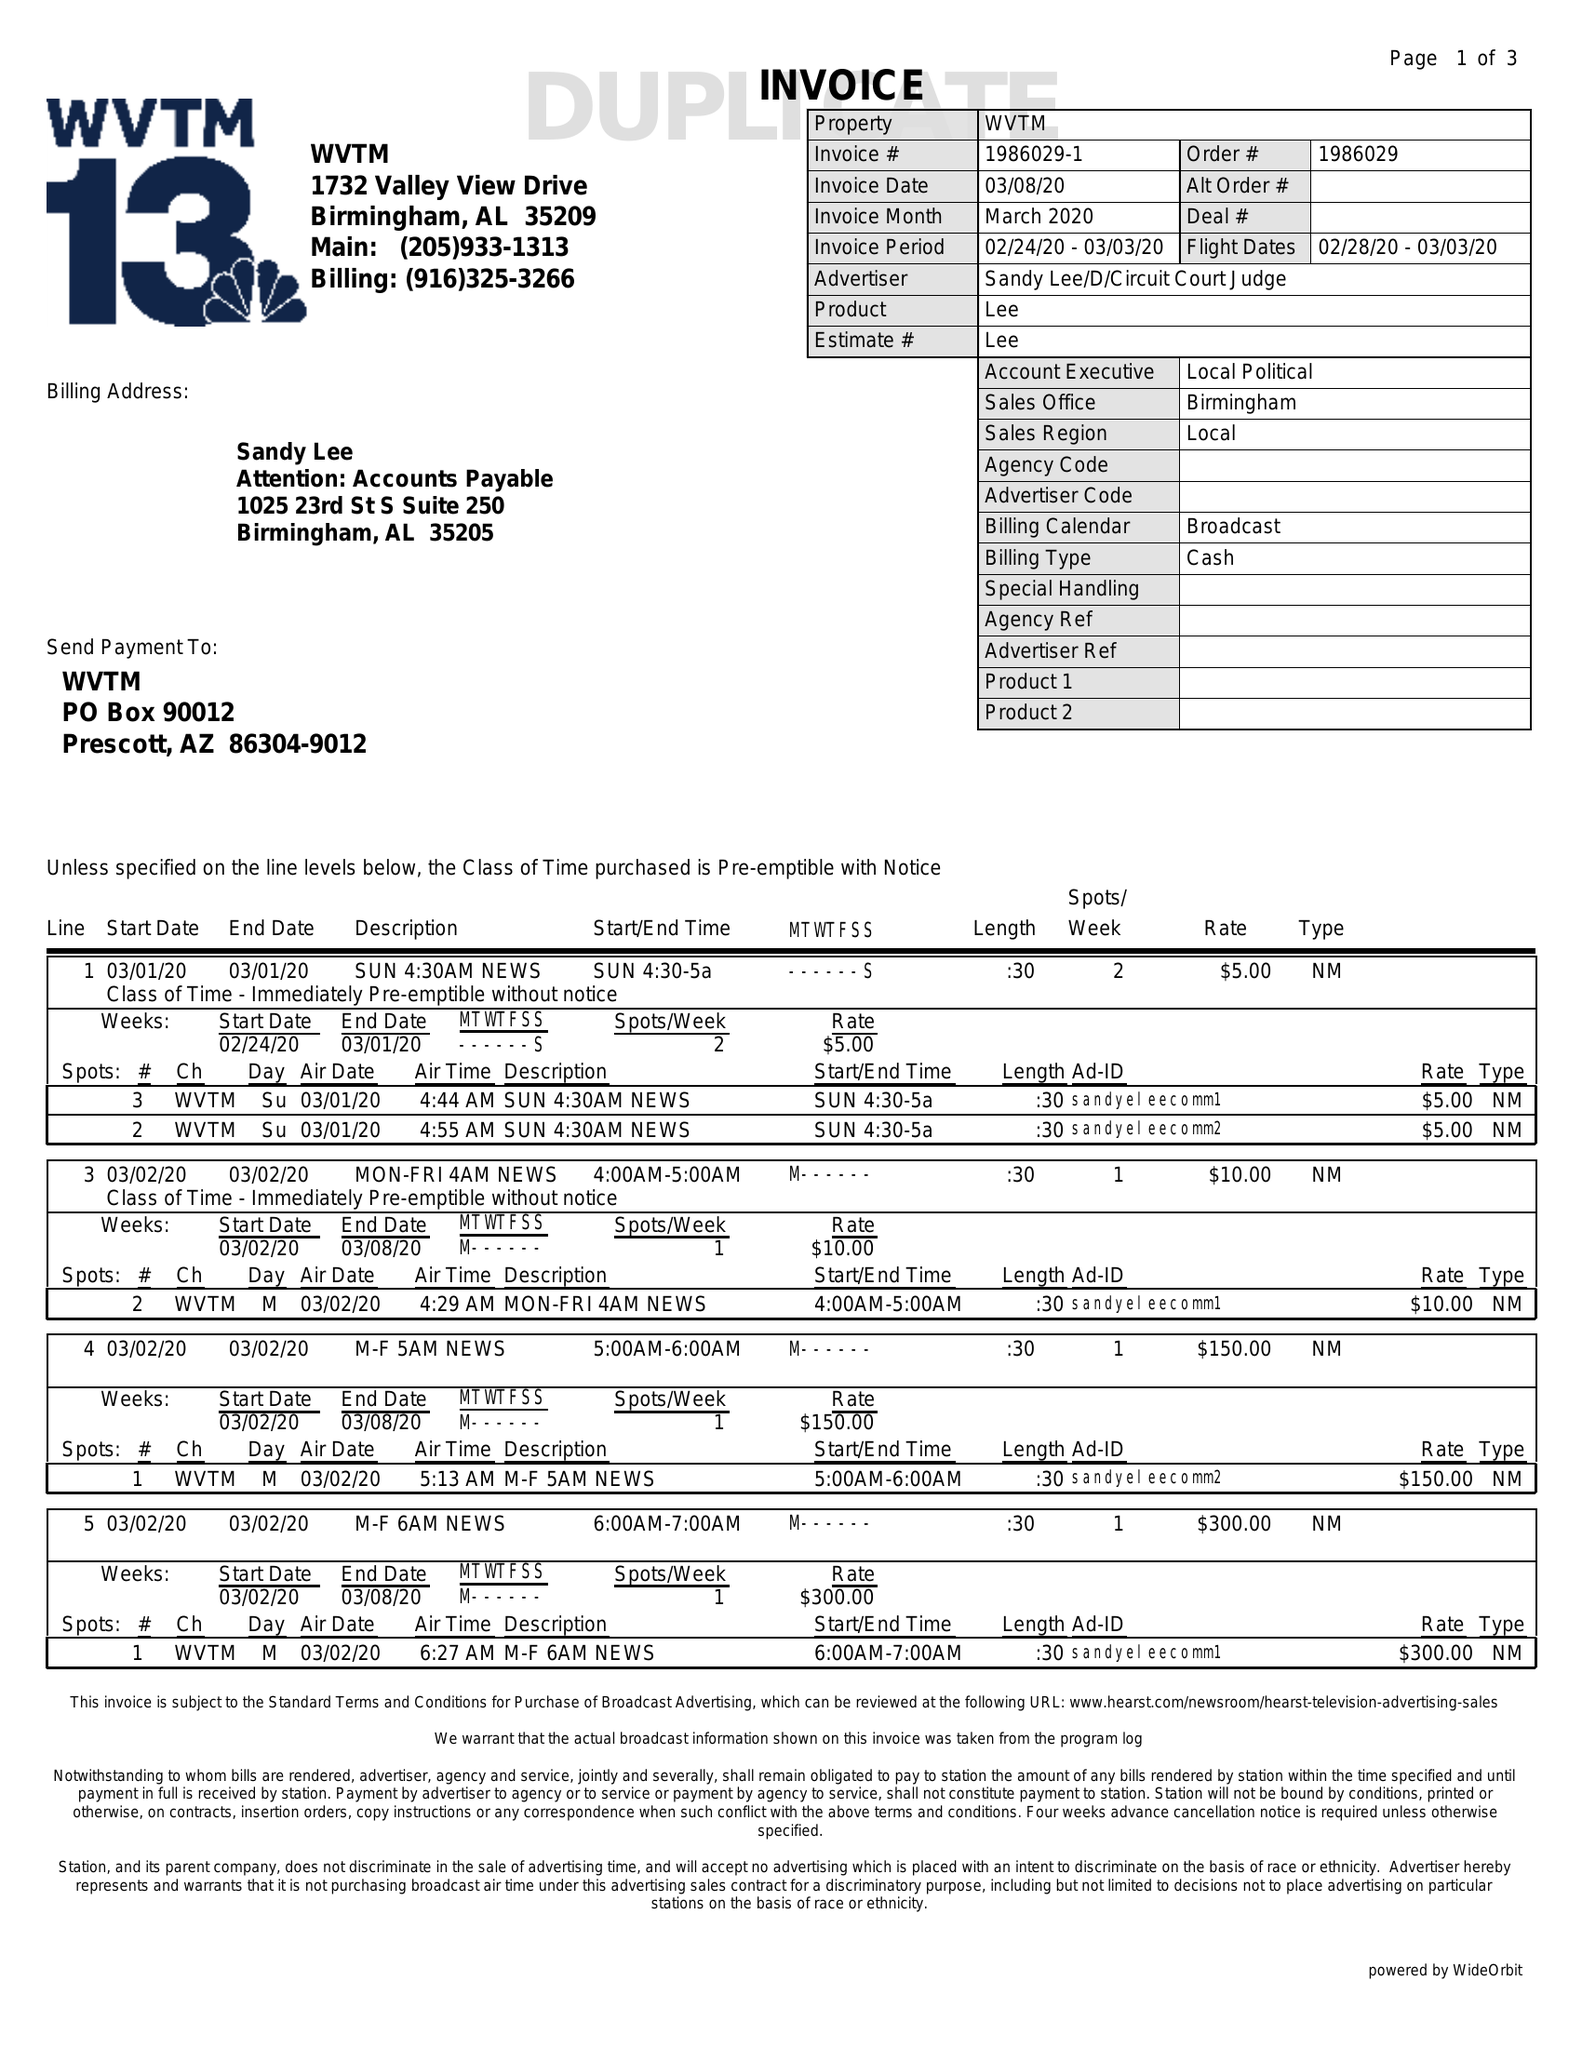What is the value for the flight_to?
Answer the question using a single word or phrase. 03/03/20 